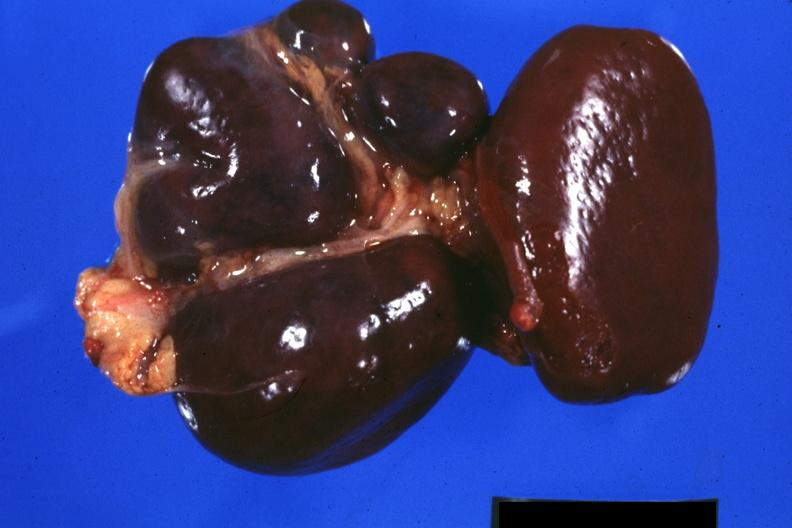s normal immature infant present?
Answer the question using a single word or phrase. No 